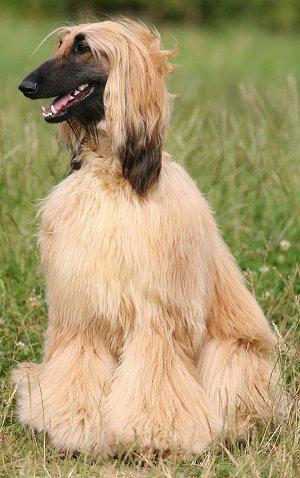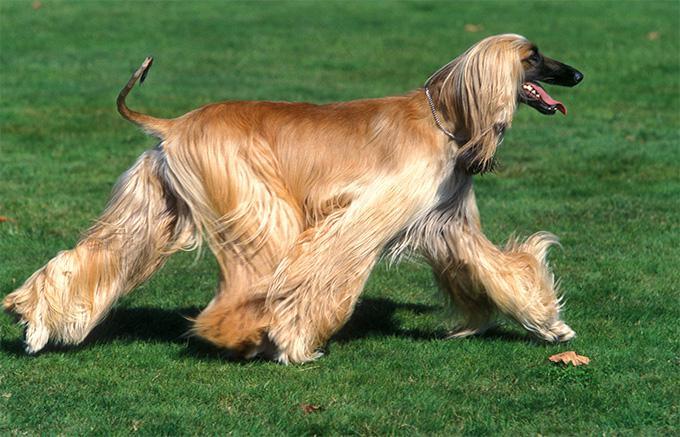The first image is the image on the left, the second image is the image on the right. Assess this claim about the two images: "One image features at least two dogs.". Correct or not? Answer yes or no. No. 